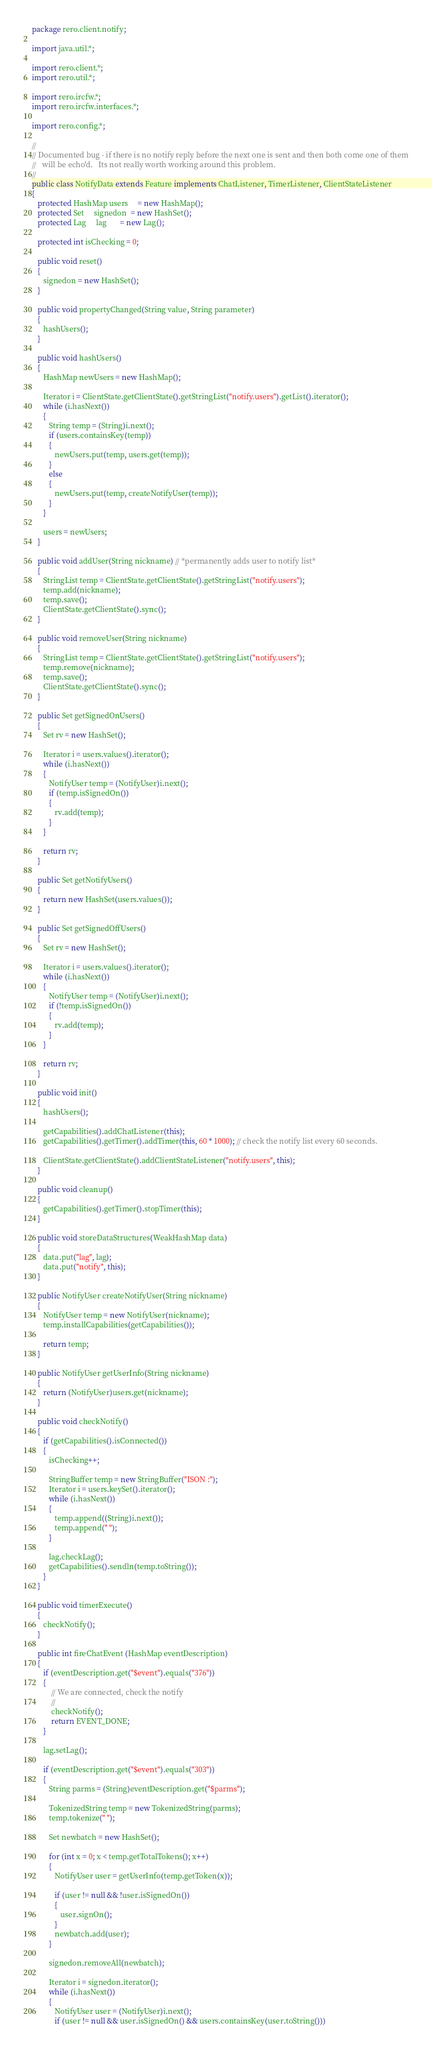Convert code to text. <code><loc_0><loc_0><loc_500><loc_500><_Java_>package rero.client.notify;

import java.util.*;

import rero.client.*;
import rero.util.*;

import rero.ircfw.*;
import rero.ircfw.interfaces.*;

import rero.config.*;

//
// Documented bug - if there is no notify reply before the next one is sent and then both come one of them
//   will be echo'd.   Its not really worth working around this problem.  
//
public class NotifyData extends Feature implements ChatListener, TimerListener, ClientStateListener
{
   protected HashMap users     = new HashMap();
   protected Set     signedon  = new HashSet();
   protected Lag     lag       = new Lag();

   protected int isChecking = 0;

   public void reset()
   {
      signedon = new HashSet();
   }

   public void propertyChanged(String value, String parameter)
   {
      hashUsers();    
   }

   public void hashUsers()
   {
      HashMap newUsers = new HashMap();

      Iterator i = ClientState.getClientState().getStringList("notify.users").getList().iterator();
      while (i.hasNext())
      {
         String temp = (String)i.next();
         if (users.containsKey(temp))
         {
            newUsers.put(temp, users.get(temp));
         }         
         else
         {
            newUsers.put(temp, createNotifyUser(temp));
         }
      }

      users = newUsers;
   }

   public void addUser(String nickname) // *permanently adds user to notify list*
   {
      StringList temp = ClientState.getClientState().getStringList("notify.users");
      temp.add(nickname);
      temp.save();
      ClientState.getClientState().sync();
   }

   public void removeUser(String nickname)
   {
      StringList temp = ClientState.getClientState().getStringList("notify.users");
      temp.remove(nickname);
      temp.save();
      ClientState.getClientState().sync();
   }

   public Set getSignedOnUsers()
   {
      Set rv = new HashSet();

      Iterator i = users.values().iterator(); 
      while (i.hasNext())
      {
         NotifyUser temp = (NotifyUser)i.next();
         if (temp.isSignedOn())
         {
            rv.add(temp);
         }
      }
 
      return rv;
   }

   public Set getNotifyUsers()
   {
      return new HashSet(users.values());
   }

   public Set getSignedOffUsers()
   {
      Set rv = new HashSet();

      Iterator i = users.values().iterator(); 
      while (i.hasNext())
      {
         NotifyUser temp = (NotifyUser)i.next();
         if (!temp.isSignedOn())
         {
            rv.add(temp);
         }
      }
 
      return rv;
   }

   public void init()
   {
      hashUsers();

      getCapabilities().addChatListener(this);
      getCapabilities().getTimer().addTimer(this, 60 * 1000); // check the notify list every 60 seconds.

      ClientState.getClientState().addClientStateListener("notify.users", this);
   }

   public void cleanup()
   {
      getCapabilities().getTimer().stopTimer(this);
   }

   public void storeDataStructures(WeakHashMap data)
   {
      data.put("lag", lag);
      data.put("notify", this);
   }

   public NotifyUser createNotifyUser(String nickname)
   {
      NotifyUser temp = new NotifyUser(nickname);
      temp.installCapabilities(getCapabilities());

      return temp;
   }

   public NotifyUser getUserInfo(String nickname)
   {
      return (NotifyUser)users.get(nickname);
   }

   public void checkNotify() 
   {
      if (getCapabilities().isConnected())
      {
         isChecking++;

         StringBuffer temp = new StringBuffer("ISON :");
         Iterator i = users.keySet().iterator();
         while (i.hasNext())
         {
            temp.append((String)i.next());
            temp.append(" ");
         }

         lag.checkLag();
         getCapabilities().sendln(temp.toString());
      }
   }

   public void timerExecute()
   {
      checkNotify();
   }

   public int fireChatEvent (HashMap eventDescription)
   {
      if (eventDescription.get("$event").equals("376"))
      {
          // We are connected, check the notify
          //
          checkNotify();
          return EVENT_DONE;
      }

      lag.setLag();

      if (eventDescription.get("$event").equals("303"))
      {
         String parms = (String)eventDescription.get("$parms");

         TokenizedString temp = new TokenizedString(parms);
         temp.tokenize(" ");

         Set newbatch = new HashSet();

         for (int x = 0; x < temp.getTotalTokens(); x++)
         {
            NotifyUser user = getUserInfo(temp.getToken(x));

            if (user != null && !user.isSignedOn())
            {
               user.signOn();         
            }          
            newbatch.add(user);
         }

         signedon.removeAll(newbatch);

         Iterator i = signedon.iterator();
         while (i.hasNext())
         {
            NotifyUser user = (NotifyUser)i.next();
            if (user != null && user.isSignedOn() && users.containsKey(user.toString()))</code> 